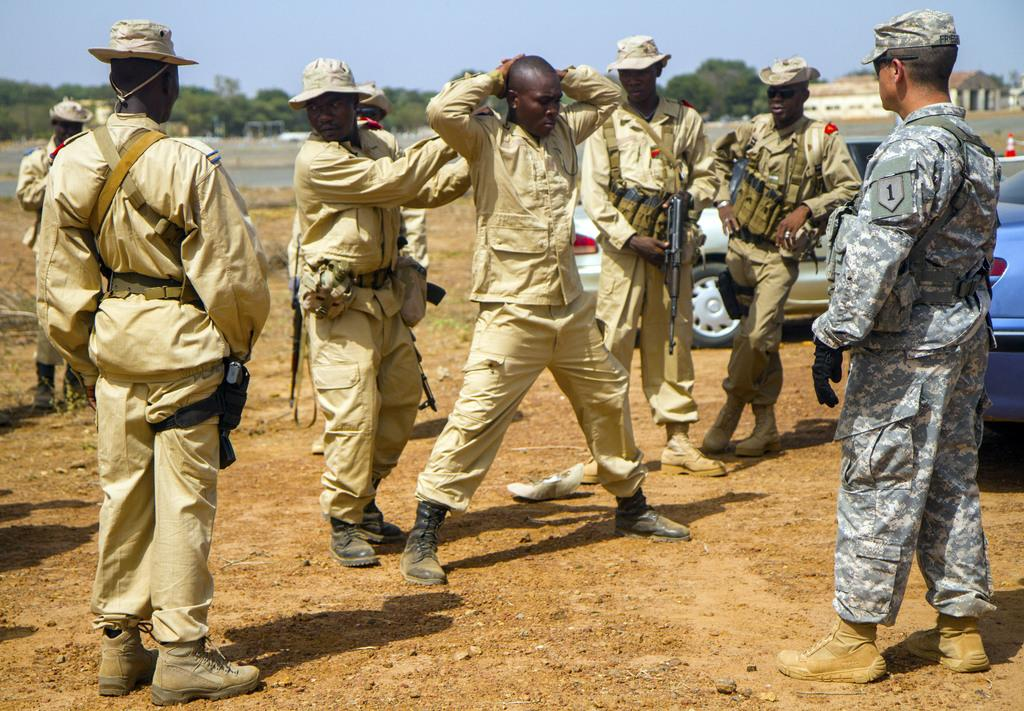What can be seen in the foreground of the image? There are persons standing in the front of the image. What are the persons holding in their hands? The persons are holding guns in their hands. What is located on the right side of the image? There are cars on the right side of the image. What type of natural scenery is visible in the background of the image? There are trees in the background of the image. What type of structure can be seen in the background of the image? There is a building in the background of the image. What type of library can be seen in the image? There is no library present in the image. What shape is the road in the image? There is no road present in the image. 